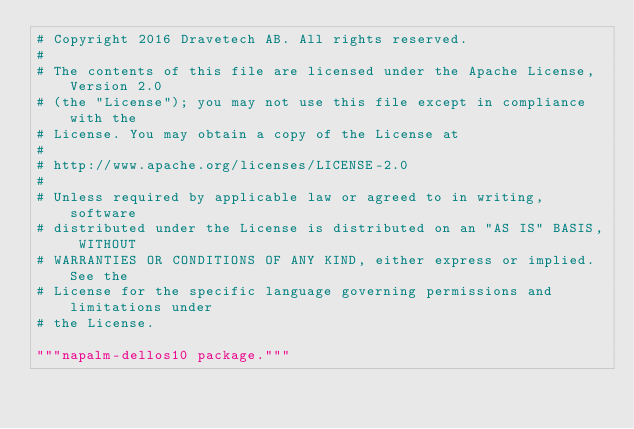Convert code to text. <code><loc_0><loc_0><loc_500><loc_500><_Python_># Copyright 2016 Dravetech AB. All rights reserved.
#
# The contents of this file are licensed under the Apache License, Version 2.0
# (the "License"); you may not use this file except in compliance with the
# License. You may obtain a copy of the License at
#
# http://www.apache.org/licenses/LICENSE-2.0
#
# Unless required by applicable law or agreed to in writing, software
# distributed under the License is distributed on an "AS IS" BASIS, WITHOUT
# WARRANTIES OR CONDITIONS OF ANY KIND, either express or implied. See the
# License for the specific language governing permissions and limitations under
# the License.

"""napalm-dellos10 package."""</code> 